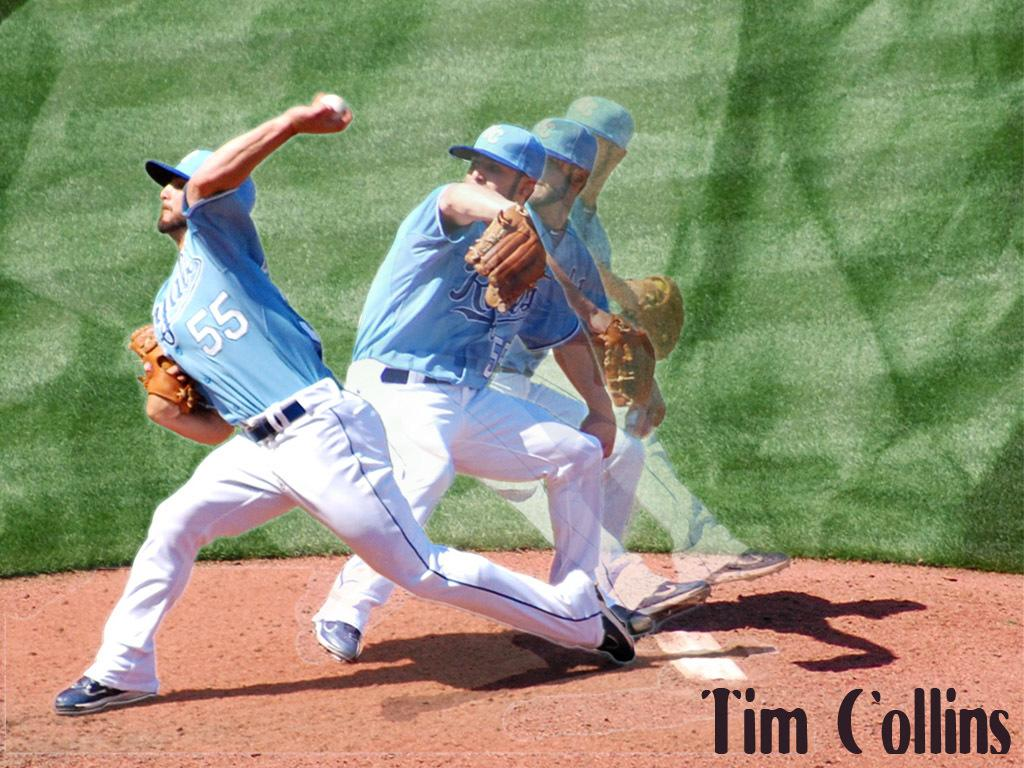<image>
Provide a brief description of the given image. a baseball player in different postions on a poster that says 'tim collins' 